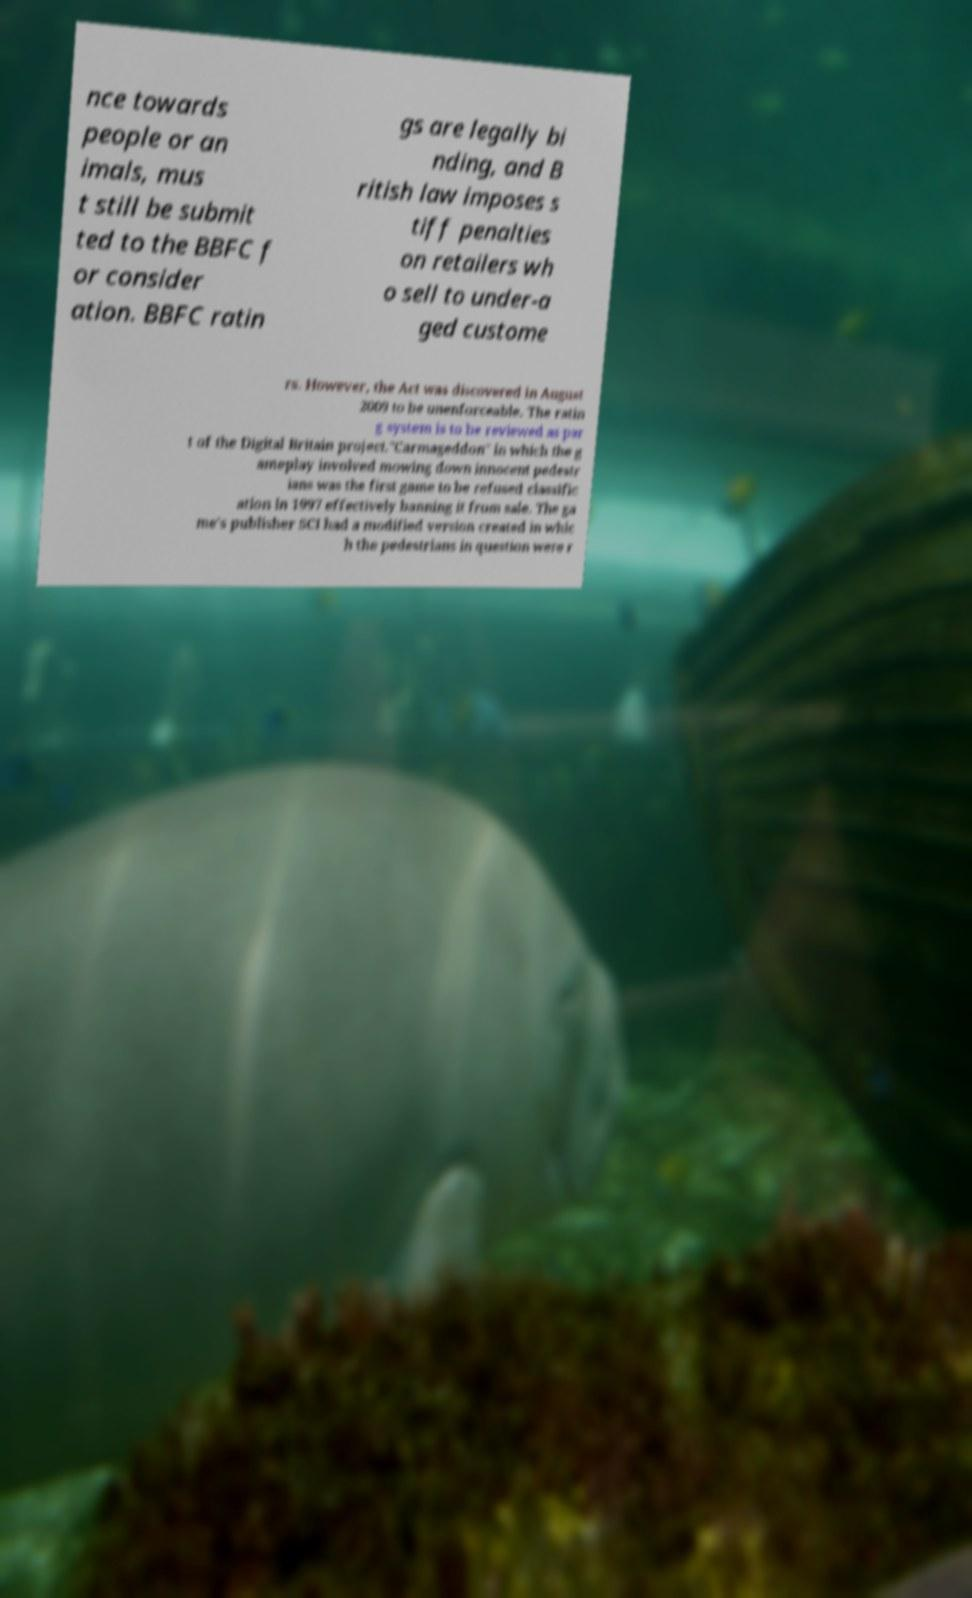Please read and relay the text visible in this image. What does it say? nce towards people or an imals, mus t still be submit ted to the BBFC f or consider ation. BBFC ratin gs are legally bi nding, and B ritish law imposes s tiff penalties on retailers wh o sell to under-a ged custome rs. However, the Act was discovered in August 2009 to be unenforceable. The ratin g system is to be reviewed as par t of the Digital Britain project."Carmageddon" in which the g ameplay involved mowing down innocent pedestr ians was the first game to be refused classific ation in 1997 effectively banning it from sale. The ga me's publisher SCI had a modified version created in whic h the pedestrians in question were r 